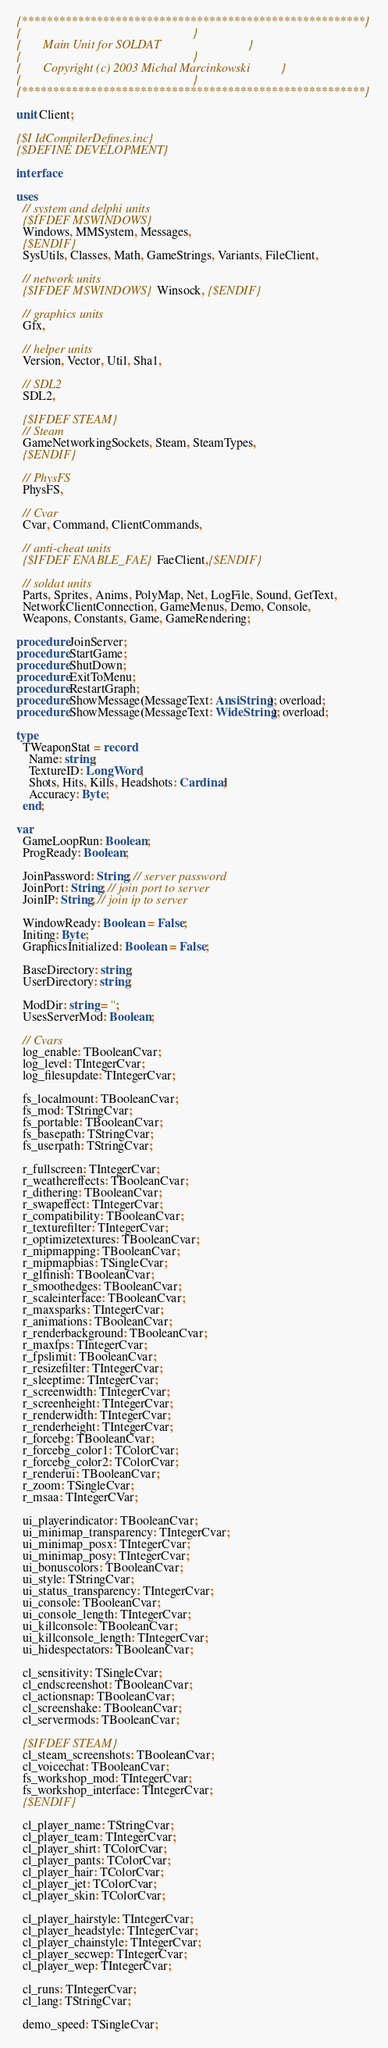<code> <loc_0><loc_0><loc_500><loc_500><_Pascal_>{*******************************************************}
{                                                       }
{       Main Unit for SOLDAT                            }
{                                                       }
{       Copyright (c) 2003 Michal Marcinkowski          }
{                                                       }
{*******************************************************}

unit Client;

{$I IdCompilerDefines.inc}
{$DEFINE DEVELOPMENT}

interface

uses
  // system and delphi units
  {$IFDEF MSWINDOWS}
  Windows, MMSystem, Messages,
  {$ENDIF}
  SysUtils, Classes, Math, GameStrings, Variants, FileClient,

  // network units
  {$IFDEF MSWINDOWS}Winsock, {$ENDIF}

  // graphics units
  Gfx,

  // helper units
  Version, Vector, Util, Sha1,

  // SDL2
  SDL2,

  {$IFDEF STEAM}
  // Steam
  GameNetworkingSockets, Steam, SteamTypes,
  {$ENDIF}

  // PhysFS
  PhysFS,

  // Cvar
  Cvar, Command, ClientCommands,

  // anti-cheat units
  {$IFDEF ENABLE_FAE}FaeClient,{$ENDIF}

  // soldat units
  Parts, Sprites, Anims, PolyMap, Net, LogFile, Sound, GetText,
  NetworkClientConnection, GameMenus, Demo, Console,
  Weapons, Constants, Game, GameRendering;

procedure JoinServer;
procedure StartGame;
procedure ShutDown;
procedure ExitToMenu;
procedure RestartGraph;
procedure ShowMessage(MessageText: AnsiString); overload;
procedure ShowMessage(MessageText: WideString); overload;

type
  TWeaponStat = record
    Name: string;
    TextureID: LongWord;
    Shots, Hits, Kills, Headshots: Cardinal;
    Accuracy: Byte;
  end;

var
  GameLoopRun: Boolean;
  ProgReady: Boolean;

  JoinPassword: String; // server password
  JoinPort: String; // join port to server
  JoinIP: String; // join ip to server

  WindowReady: Boolean = False;
  Initing: Byte;
  GraphicsInitialized: Boolean = False;

  BaseDirectory: string;
  UserDirectory: string;

  ModDir: string = '';
  UsesServerMod: Boolean;

  // Cvars
  log_enable: TBooleanCvar;
  log_level: TIntegerCvar;
  log_filesupdate: TIntegerCvar;

  fs_localmount: TBooleanCvar;
  fs_mod: TStringCvar;
  fs_portable: TBooleanCvar;
  fs_basepath: TStringCvar;
  fs_userpath: TStringCvar;

  r_fullscreen: TIntegerCvar;
  r_weathereffects: TBooleanCvar;
  r_dithering: TBooleanCvar;
  r_swapeffect: TIntegerCvar;
  r_compatibility: TBooleanCvar;
  r_texturefilter: TIntegerCvar;
  r_optimizetextures: TBooleanCvar;
  r_mipmapping: TBooleanCvar;
  r_mipmapbias: TSingleCvar;
  r_glfinish: TBooleanCvar;
  r_smoothedges: TBooleanCvar;
  r_scaleinterface: TBooleanCvar;
  r_maxsparks: TIntegerCvar;
  r_animations: TBooleanCvar;
  r_renderbackground: TBooleanCvar;
  r_maxfps: TIntegerCvar;
  r_fpslimit: TBooleanCvar;
  r_resizefilter: TIntegerCvar;
  r_sleeptime: TIntegerCvar;
  r_screenwidth: TIntegerCvar;
  r_screenheight: TIntegerCvar;
  r_renderwidth: TIntegerCvar;
  r_renderheight: TIntegerCvar;
  r_forcebg: TBooleanCvar;
  r_forcebg_color1: TColorCvar;
  r_forcebg_color2: TColorCvar;
  r_renderui: TBooleanCvar;
  r_zoom: TSingleCvar;
  r_msaa: TIntegerCVar;

  ui_playerindicator: TBooleanCvar;
  ui_minimap_transparency: TIntegerCvar;
  ui_minimap_posx: TIntegerCvar;
  ui_minimap_posy: TIntegerCvar;
  ui_bonuscolors: TBooleanCvar;
  ui_style: TStringCvar;
  ui_status_transparency: TIntegerCvar;
  ui_console: TBooleanCvar;
  ui_console_length: TIntegerCvar;
  ui_killconsole: TBooleanCvar;
  ui_killconsole_length: TIntegerCvar;
  ui_hidespectators: TBooleanCvar;

  cl_sensitivity: TSingleCvar;
  cl_endscreenshot: TBooleanCvar;
  cl_actionsnap: TBooleanCvar;
  cl_screenshake: TBooleanCvar;
  cl_servermods: TBooleanCvar;

  {$IFDEF STEAM}
  cl_steam_screenshots: TBooleanCvar;
  cl_voicechat: TBooleanCvar;
  fs_workshop_mod: TIntegerCvar;
  fs_workshop_interface: TIntegerCvar;
  {$ENDIF}

  cl_player_name: TStringCvar;
  cl_player_team: TIntegerCvar;
  cl_player_shirt: TColorCvar;
  cl_player_pants: TColorCvar;
  cl_player_hair: TColorCvar;
  cl_player_jet: TColorCvar;
  cl_player_skin: TColorCvar;

  cl_player_hairstyle: TIntegerCvar;
  cl_player_headstyle: TIntegerCvar;
  cl_player_chainstyle: TIntegerCvar;
  cl_player_secwep: TIntegerCvar;
  cl_player_wep: TIntegerCvar;

  cl_runs: TIntegerCvar;
  cl_lang: TStringCvar;

  demo_speed: TSingleCvar;</code> 